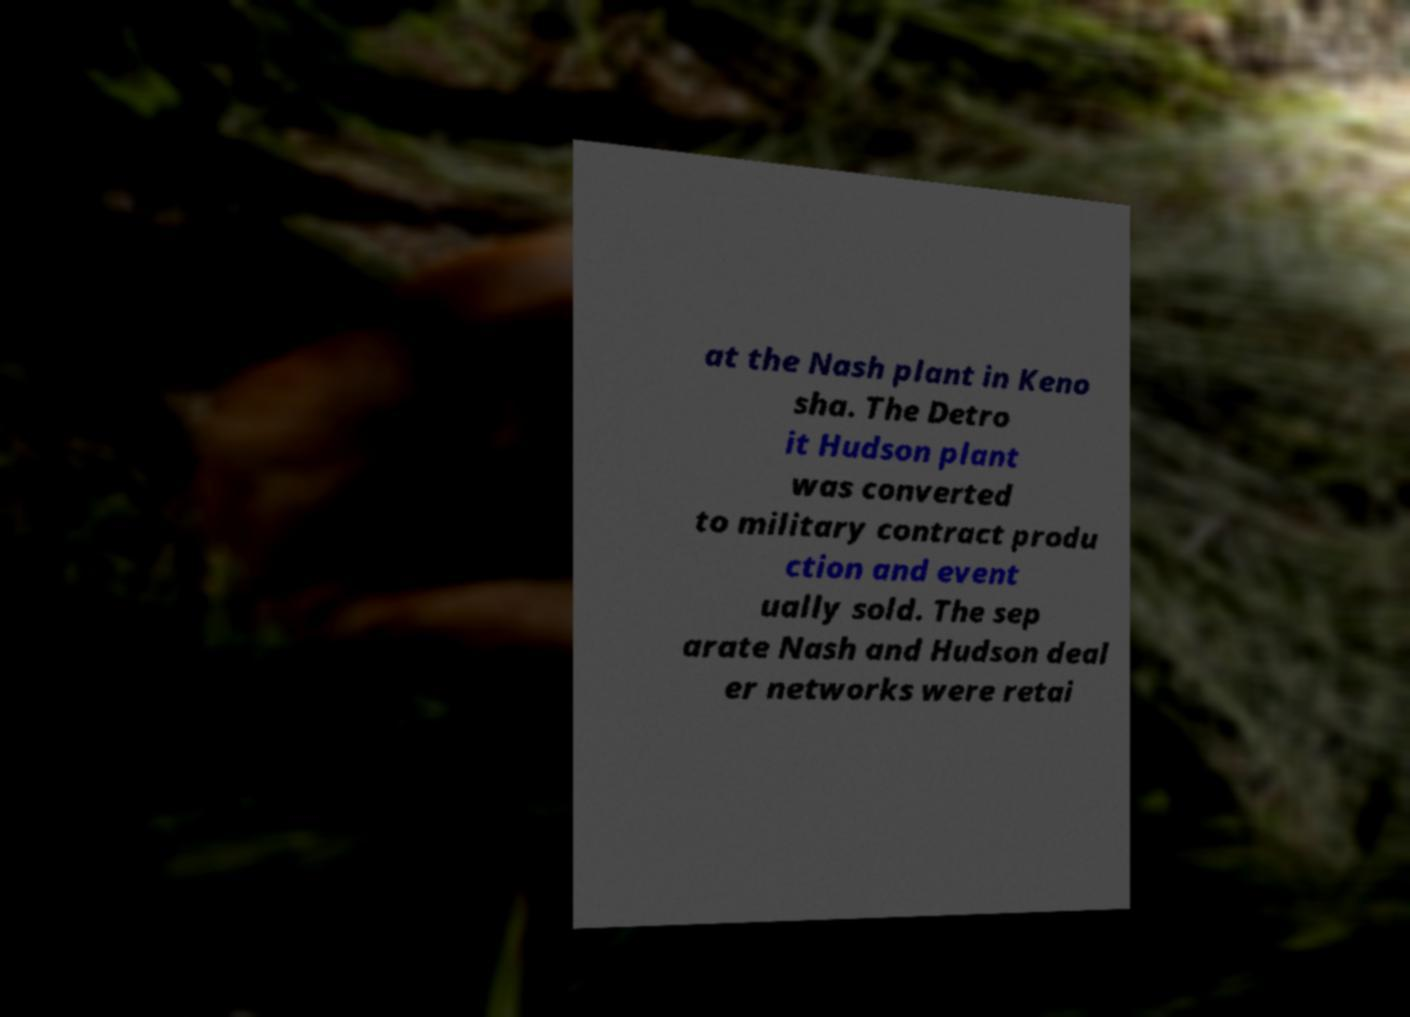Can you accurately transcribe the text from the provided image for me? at the Nash plant in Keno sha. The Detro it Hudson plant was converted to military contract produ ction and event ually sold. The sep arate Nash and Hudson deal er networks were retai 